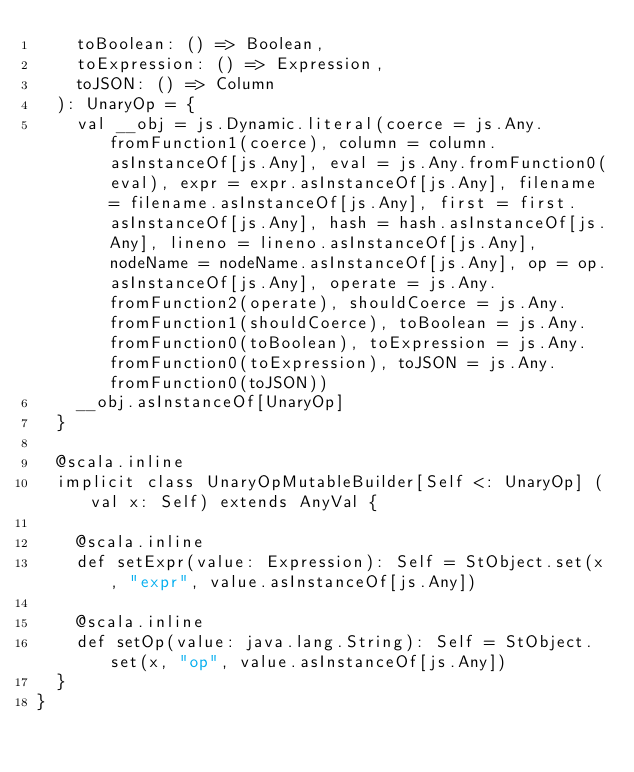<code> <loc_0><loc_0><loc_500><loc_500><_Scala_>    toBoolean: () => Boolean,
    toExpression: () => Expression,
    toJSON: () => Column
  ): UnaryOp = {
    val __obj = js.Dynamic.literal(coerce = js.Any.fromFunction1(coerce), column = column.asInstanceOf[js.Any], eval = js.Any.fromFunction0(eval), expr = expr.asInstanceOf[js.Any], filename = filename.asInstanceOf[js.Any], first = first.asInstanceOf[js.Any], hash = hash.asInstanceOf[js.Any], lineno = lineno.asInstanceOf[js.Any], nodeName = nodeName.asInstanceOf[js.Any], op = op.asInstanceOf[js.Any], operate = js.Any.fromFunction2(operate), shouldCoerce = js.Any.fromFunction1(shouldCoerce), toBoolean = js.Any.fromFunction0(toBoolean), toExpression = js.Any.fromFunction0(toExpression), toJSON = js.Any.fromFunction0(toJSON))
    __obj.asInstanceOf[UnaryOp]
  }
  
  @scala.inline
  implicit class UnaryOpMutableBuilder[Self <: UnaryOp] (val x: Self) extends AnyVal {
    
    @scala.inline
    def setExpr(value: Expression): Self = StObject.set(x, "expr", value.asInstanceOf[js.Any])
    
    @scala.inline
    def setOp(value: java.lang.String): Self = StObject.set(x, "op", value.asInstanceOf[js.Any])
  }
}
</code> 